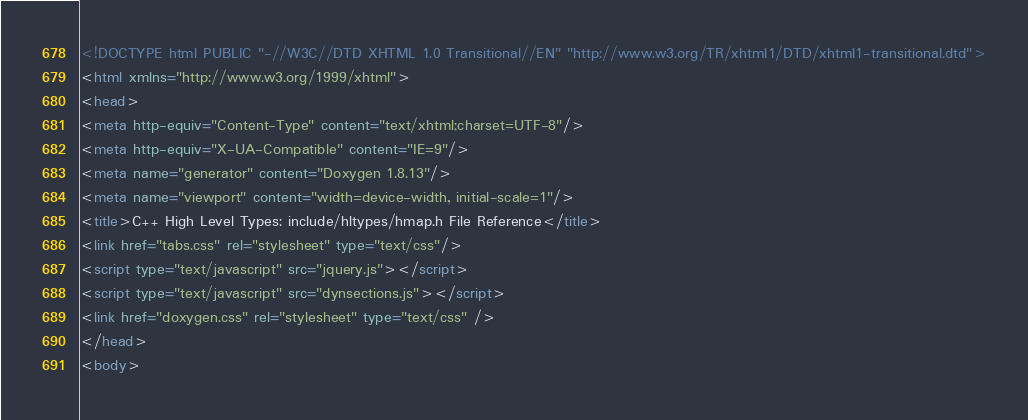<code> <loc_0><loc_0><loc_500><loc_500><_HTML_><!DOCTYPE html PUBLIC "-//W3C//DTD XHTML 1.0 Transitional//EN" "http://www.w3.org/TR/xhtml1/DTD/xhtml1-transitional.dtd">
<html xmlns="http://www.w3.org/1999/xhtml">
<head>
<meta http-equiv="Content-Type" content="text/xhtml;charset=UTF-8"/>
<meta http-equiv="X-UA-Compatible" content="IE=9"/>
<meta name="generator" content="Doxygen 1.8.13"/>
<meta name="viewport" content="width=device-width, initial-scale=1"/>
<title>C++ High Level Types: include/hltypes/hmap.h File Reference</title>
<link href="tabs.css" rel="stylesheet" type="text/css"/>
<script type="text/javascript" src="jquery.js"></script>
<script type="text/javascript" src="dynsections.js"></script>
<link href="doxygen.css" rel="stylesheet" type="text/css" />
</head>
<body></code> 